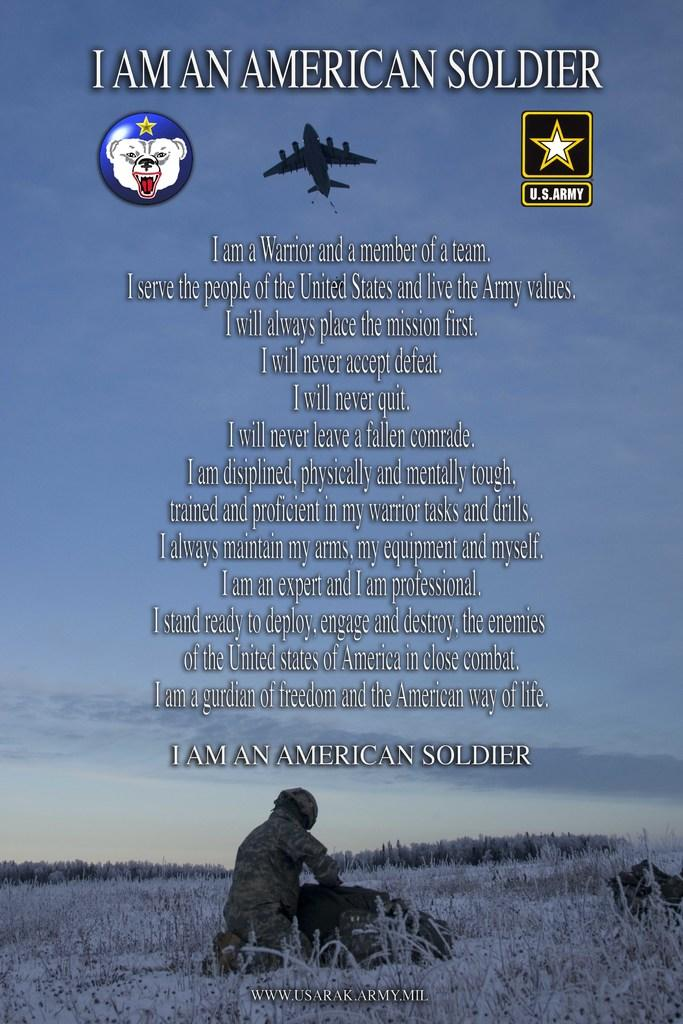Provide a one-sentence caption for the provided image. Advertisement by the U.S. Army with a soldier and jet in it. 